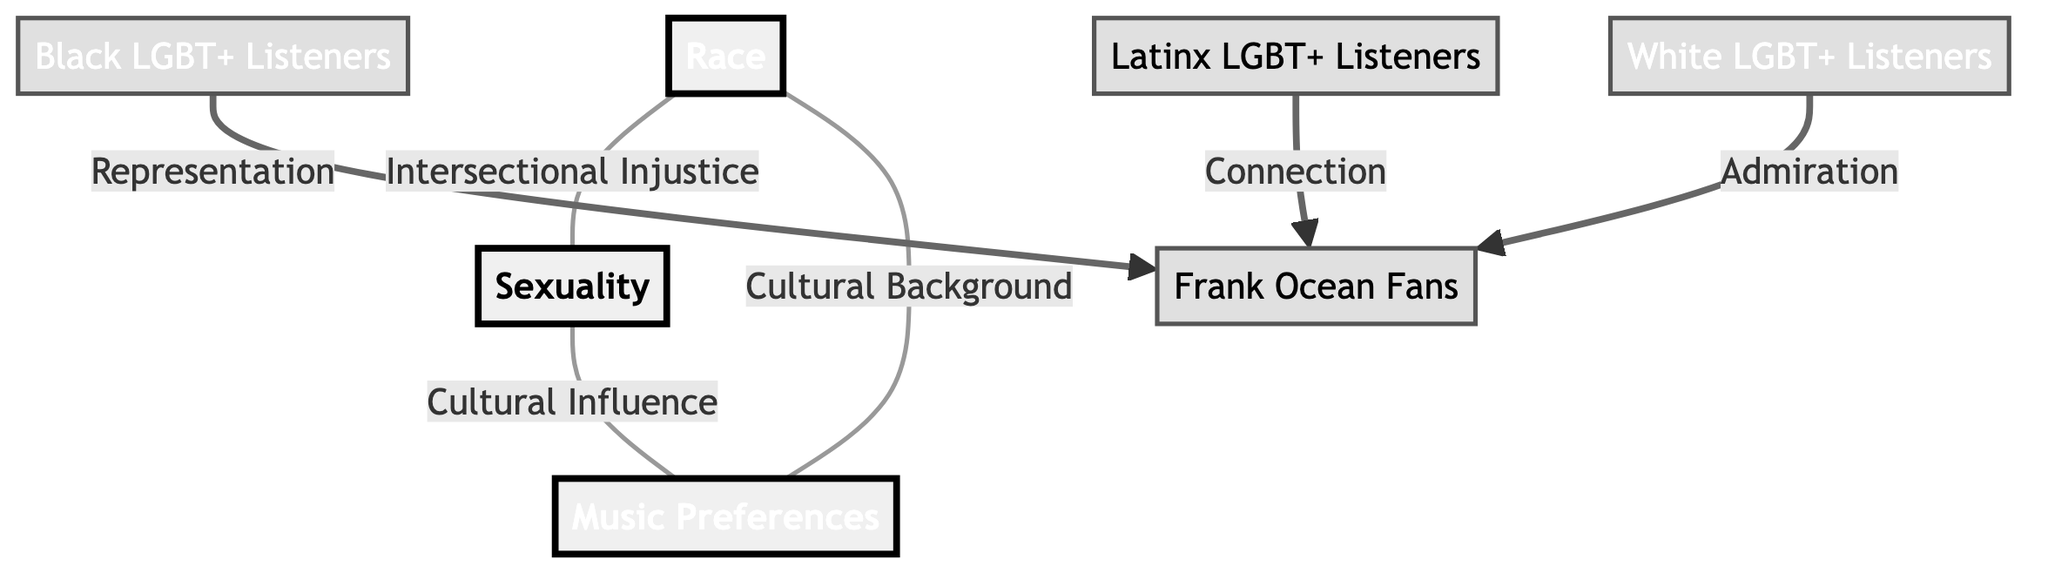What are the three main categories represented in the diagram? The diagram shows three main categories: Race, Sexuality, and Music Preferences. Each category is clearly labeled and differentiated by its own color.
Answer: Race, Sexuality, Music Preferences How many subcategories are present in the diagram? There are three subcategories represented as different groups under Race and Sexuality: Black LGBT+ Listeners, Latinx LGBT+ Listeners, and White LGBT+ Listeners, making a total of three subcategories.
Answer: 3 What connects Race and Sexuality in the diagram? The link between Race and Sexuality is represented as "Intersectional Injustice". This connection indicates the relationship showing how race affects the experience of sexuality among individuals.
Answer: Intersectional Injustice Which group has a representation link to Frank Ocean? The group that has a representation link to Frank Ocean is Black LGBT+ Listeners. This indicates a specific connection between the demographic and the artist.
Answer: Black LGBT+ Listeners What cultural influence connects Sexuality and Music Preferences? The diagram states that "Cultural Influence" connects Sexuality to Music Preferences, highlighting how one’s sexual orientation can shape music tastes among these populations.
Answer: Cultural Influence Which group is associated with admiration for Frank Ocean? The group associated with admiration for Frank Ocean is White LGBT+ Listeners. This indicates a particular appreciation or respect for the artist among this demographic.
Answer: White LGBT+ Listeners How does Cultural Background relate to Music Preferences? The diagram indicates that "Cultural Background" connects Race and Music Preferences, suggesting that individuals’ racial identities influence their musical tastes.
Answer: Cultural Background What is the style color of the Race node? The Race node is styled in the color #FF5733, which corresponds to a specific shade of red in the diagram.
Answer: #FF5733 What indicates the connection between Latinx LGBT+ Listeners and Frank Ocean? Latinx LGBT+ Listeners have a link to Frank Ocean labeled "Connection", illustrating a relational element to how this group engages with the artist's music.
Answer: Connection 